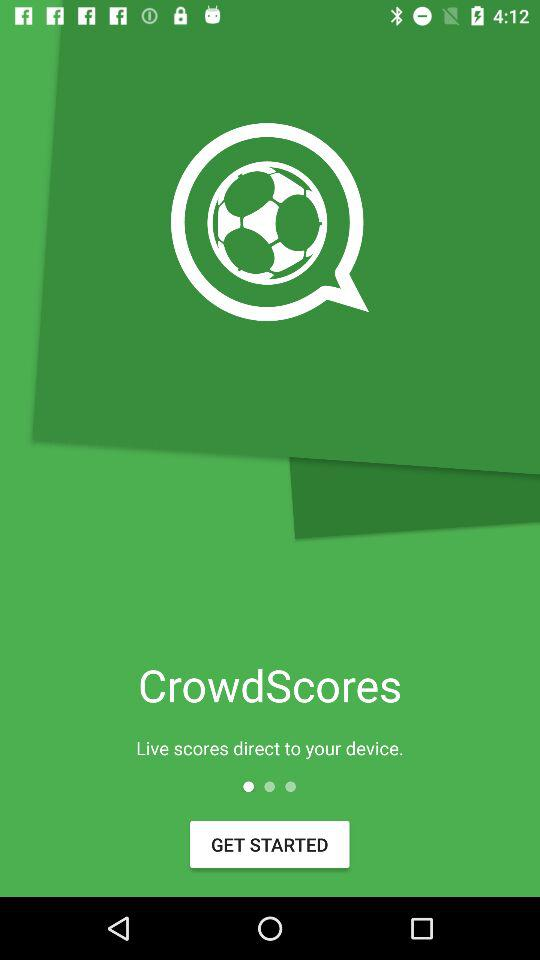If the pager indicator is at the 3rd position, how many more positions are there to scroll through?
Answer the question using a single word or phrase. 2 